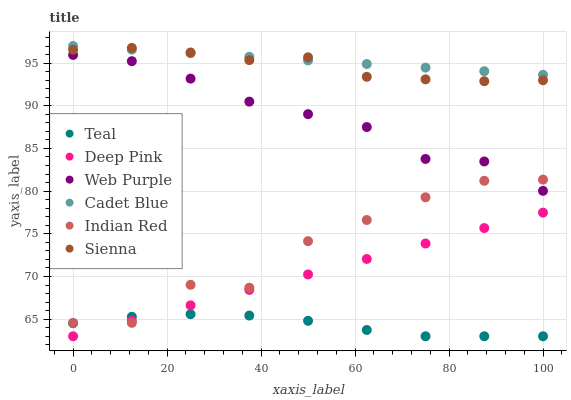Does Teal have the minimum area under the curve?
Answer yes or no. Yes. Does Cadet Blue have the maximum area under the curve?
Answer yes or no. Yes. Does Sienna have the minimum area under the curve?
Answer yes or no. No. Does Sienna have the maximum area under the curve?
Answer yes or no. No. Is Cadet Blue the smoothest?
Answer yes or no. Yes. Is Indian Red the roughest?
Answer yes or no. Yes. Is Teal the smoothest?
Answer yes or no. No. Is Teal the roughest?
Answer yes or no. No. Does Teal have the lowest value?
Answer yes or no. Yes. Does Sienna have the lowest value?
Answer yes or no. No. Does Cadet Blue have the highest value?
Answer yes or no. Yes. Does Sienna have the highest value?
Answer yes or no. No. Is Teal less than Cadet Blue?
Answer yes or no. Yes. Is Cadet Blue greater than Deep Pink?
Answer yes or no. Yes. Does Indian Red intersect Deep Pink?
Answer yes or no. Yes. Is Indian Red less than Deep Pink?
Answer yes or no. No. Is Indian Red greater than Deep Pink?
Answer yes or no. No. Does Teal intersect Cadet Blue?
Answer yes or no. No. 